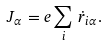<formula> <loc_0><loc_0><loc_500><loc_500>J _ { \alpha } = e \sum _ { i } \, \dot { r } _ { i \alpha } .</formula> 